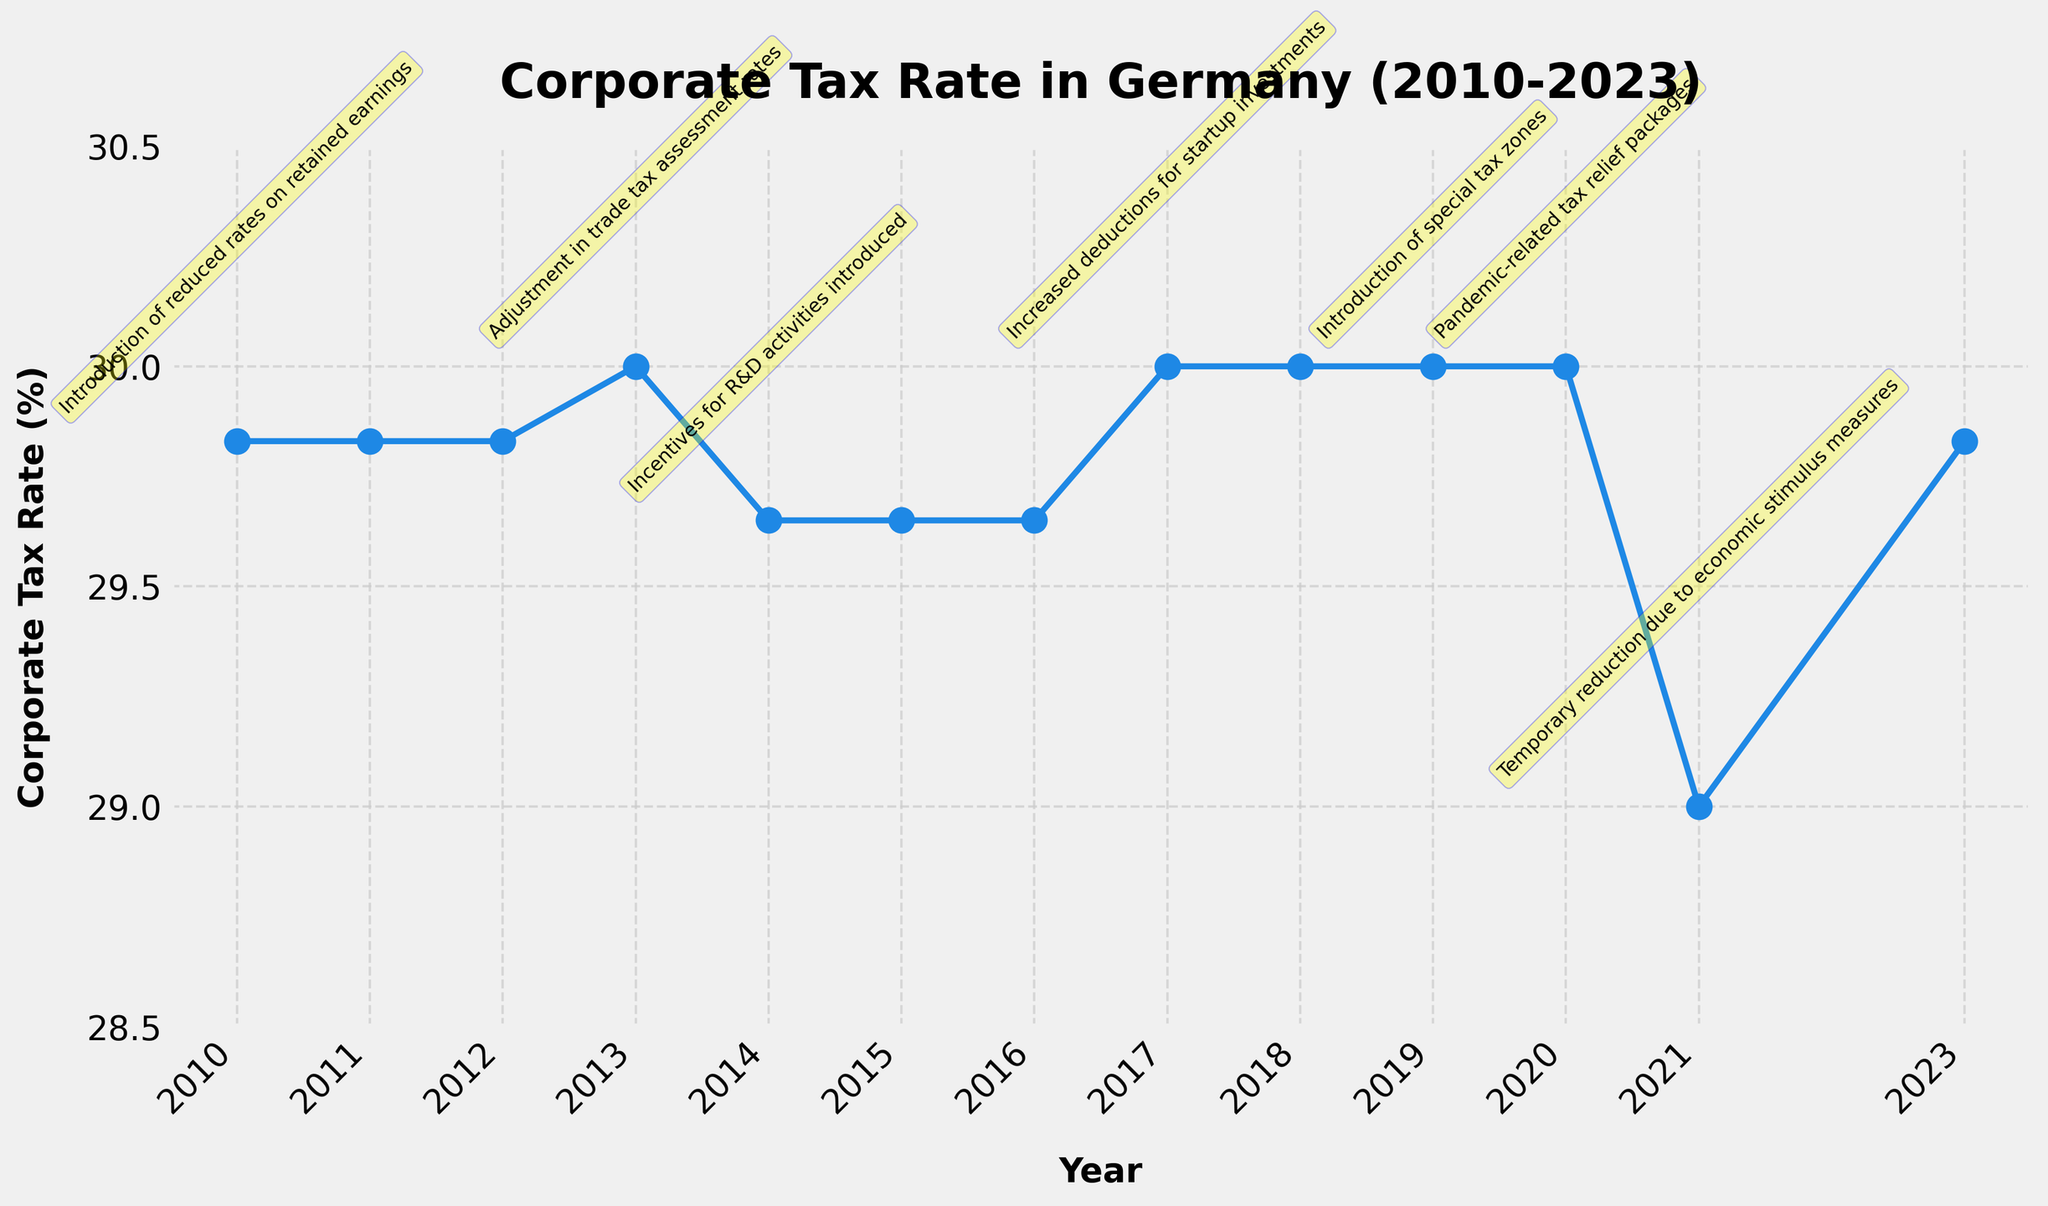What is the title of the figure? The title is usually located at the top of the figure. The figure title is "Corporate Tax Rate in Germany (2010-2023)."
Answer: Corporate Tax Rate in Germany (2010-2023) How many years are displayed on the x-axis? By counting the number of tick labels on the x-axis, we see a range from 2010 to 2023, inclusive.
Answer: 14 What is the highest corporate tax rate recorded in the time series? The highest tax rate can be identified by looking at the highest point on the y-axis of the plot, which is 30.00%.
Answer: 30.00% In which year did Germany see a significant reduction in the corporate tax rate to 29.00%? By observing the trend line and annotations, the significant reduction to 29.00% occurred in the year that also had annotations about economic stimulus measures.
Answer: 2021 How did corporate tax rates change from 2017 to 2018? By examining the plot between 2017 and 2018, the rate remained unchanged at 30.00%.
Answer: No change What was the impact on corporate tax rates when the "Incentives for R&D activities" were introduced? By locating the annotation and corresponding data point for the "Incentives for R&D" on the plot, the tax rate in 2014 slightly decreased to 29.65%.
Answer: Decreased to 29.65% Which year had the introduction of "special tax zones" and what was the corporate tax rate during that year? By finding the annotation mentioning "special tax zones", we identify the year as 2019 with a corporate tax rate of 30.00%.
Answer: 2019, 30.00% Compare the corporate tax rate in 2010 and 2023. Which year had a higher rate? By comparing the data points for 2010 and 2023, the rate in both years is 29.83%, indicating no difference.
Answer: Both are the same How many times did the corporate tax rate change over the years displayed? By counting the distinct changes in the plot's trend line, there were five changes visible on the plot.
Answer: 5 changes What was the corporate tax rate during the "pandemic-related tax relief packages"? Identifying the annotation for "pandemic-related tax relief packages", the tax rate in 2020 can be seen as 30.00%.
Answer: 30.00% 